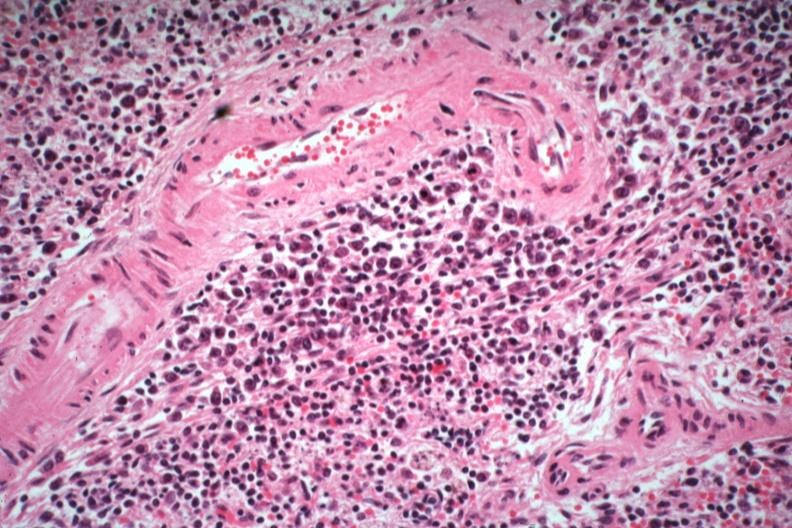what is present?
Answer the question using a single word or phrase. Spleen 